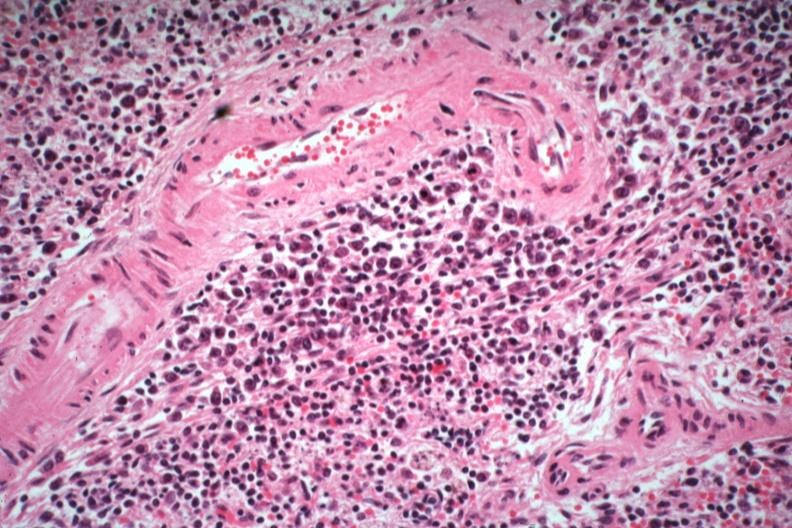what is present?
Answer the question using a single word or phrase. Spleen 